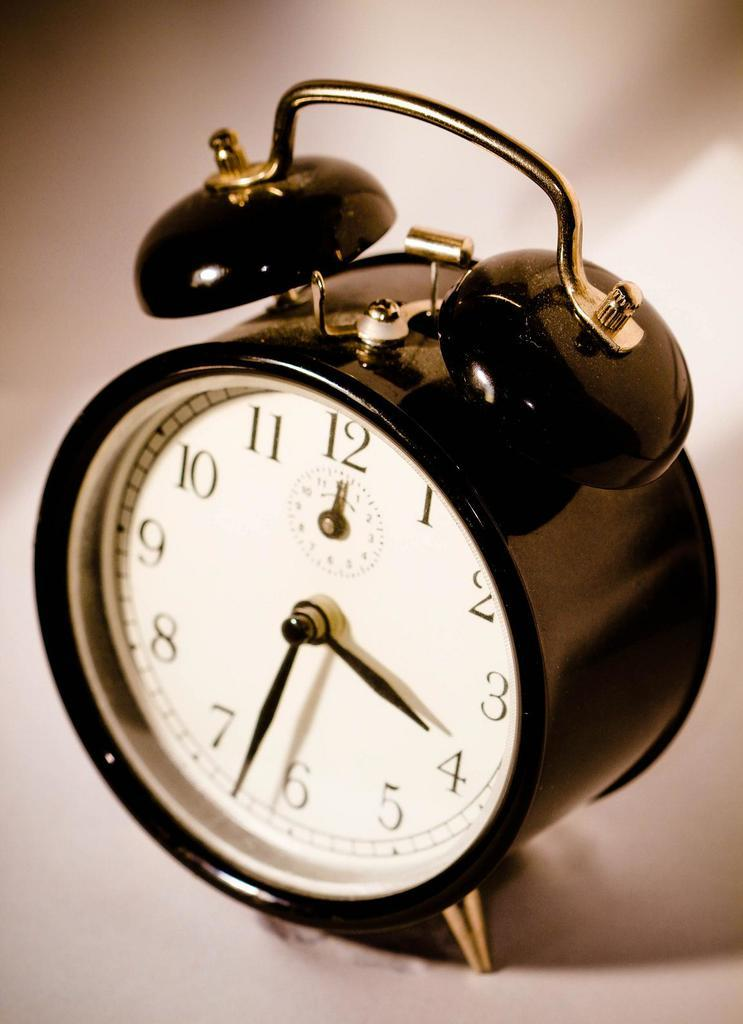Provide a one-sentence caption for the provided image. An old fashion alarm clock showing that it is 3:33. 